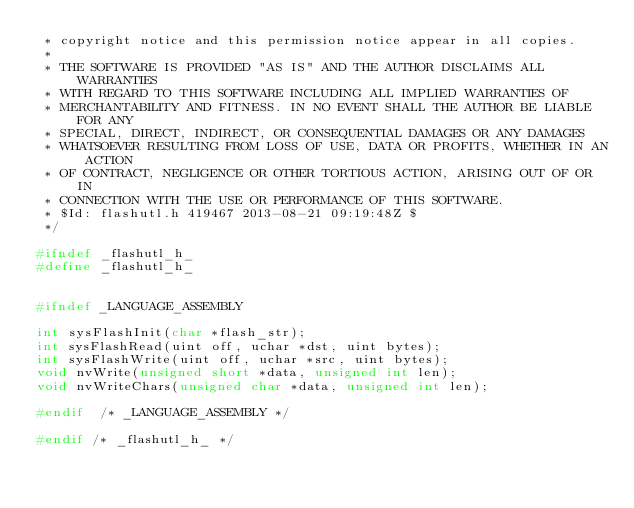<code> <loc_0><loc_0><loc_500><loc_500><_C_> * copyright notice and this permission notice appear in all copies.
 * 
 * THE SOFTWARE IS PROVIDED "AS IS" AND THE AUTHOR DISCLAIMS ALL WARRANTIES
 * WITH REGARD TO THIS SOFTWARE INCLUDING ALL IMPLIED WARRANTIES OF
 * MERCHANTABILITY AND FITNESS. IN NO EVENT SHALL THE AUTHOR BE LIABLE FOR ANY
 * SPECIAL, DIRECT, INDIRECT, OR CONSEQUENTIAL DAMAGES OR ANY DAMAGES
 * WHATSOEVER RESULTING FROM LOSS OF USE, DATA OR PROFITS, WHETHER IN AN ACTION
 * OF CONTRACT, NEGLIGENCE OR OTHER TORTIOUS ACTION, ARISING OUT OF OR IN
 * CONNECTION WITH THE USE OR PERFORMANCE OF THIS SOFTWARE.
 * $Id: flashutl.h 419467 2013-08-21 09:19:48Z $
 */

#ifndef _flashutl_h_
#define _flashutl_h_


#ifndef _LANGUAGE_ASSEMBLY

int	sysFlashInit(char *flash_str);
int sysFlashRead(uint off, uchar *dst, uint bytes);
int sysFlashWrite(uint off, uchar *src, uint bytes);
void nvWrite(unsigned short *data, unsigned int len);
void nvWriteChars(unsigned char *data, unsigned int len);

#endif	/* _LANGUAGE_ASSEMBLY */

#endif /* _flashutl_h_ */
</code> 